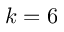<formula> <loc_0><loc_0><loc_500><loc_500>k = 6</formula> 